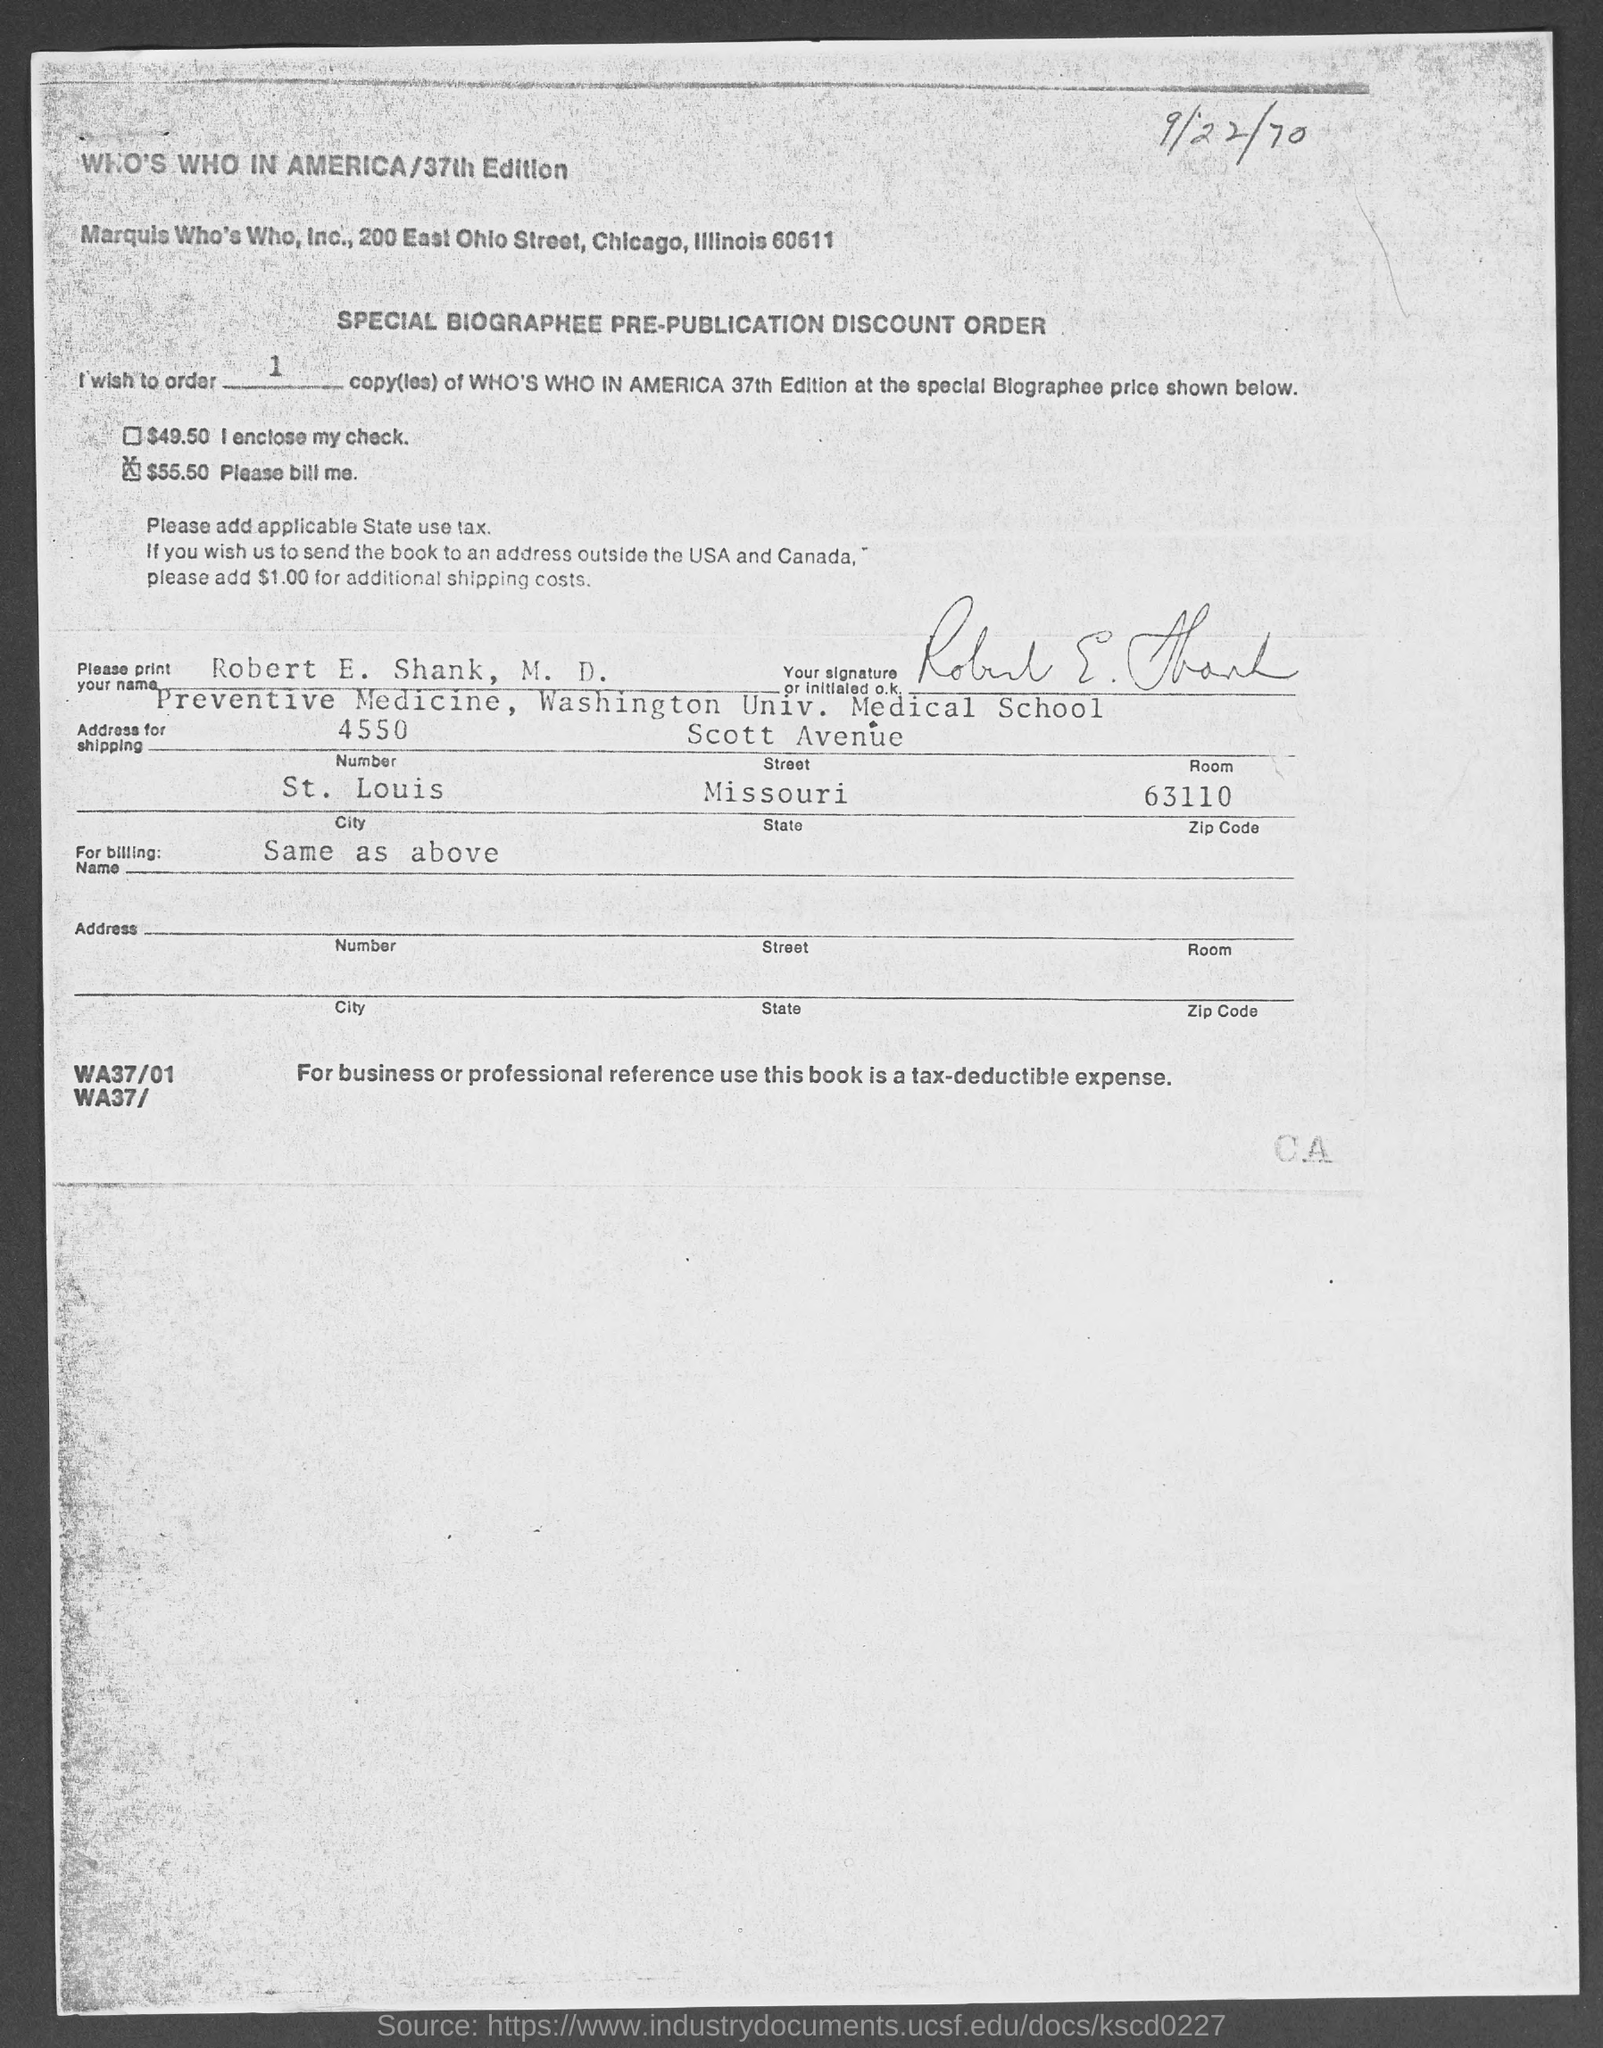In which state is marquis who's who, inc., located ?
Make the answer very short. Illinois. In which state  washington univ. medical school located ?
Provide a short and direct response. Missouri. 